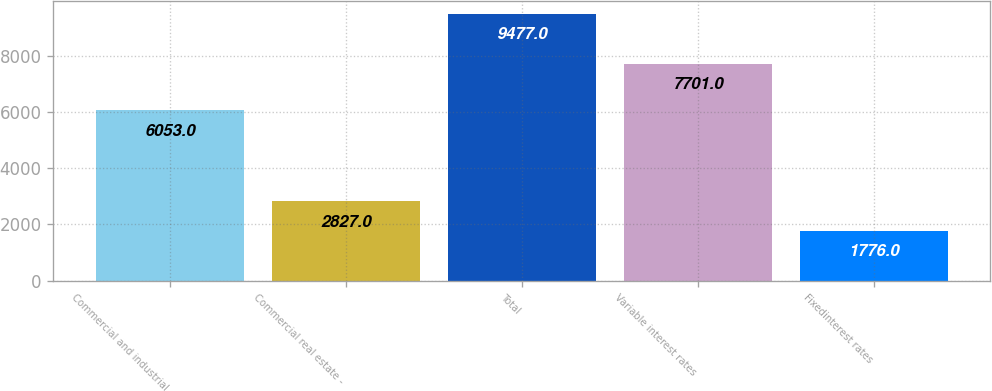<chart> <loc_0><loc_0><loc_500><loc_500><bar_chart><fcel>Commercial and industrial<fcel>Commercial real estate -<fcel>Total<fcel>Variable interest rates<fcel>Fixedinterest rates<nl><fcel>6053<fcel>2827<fcel>9477<fcel>7701<fcel>1776<nl></chart> 